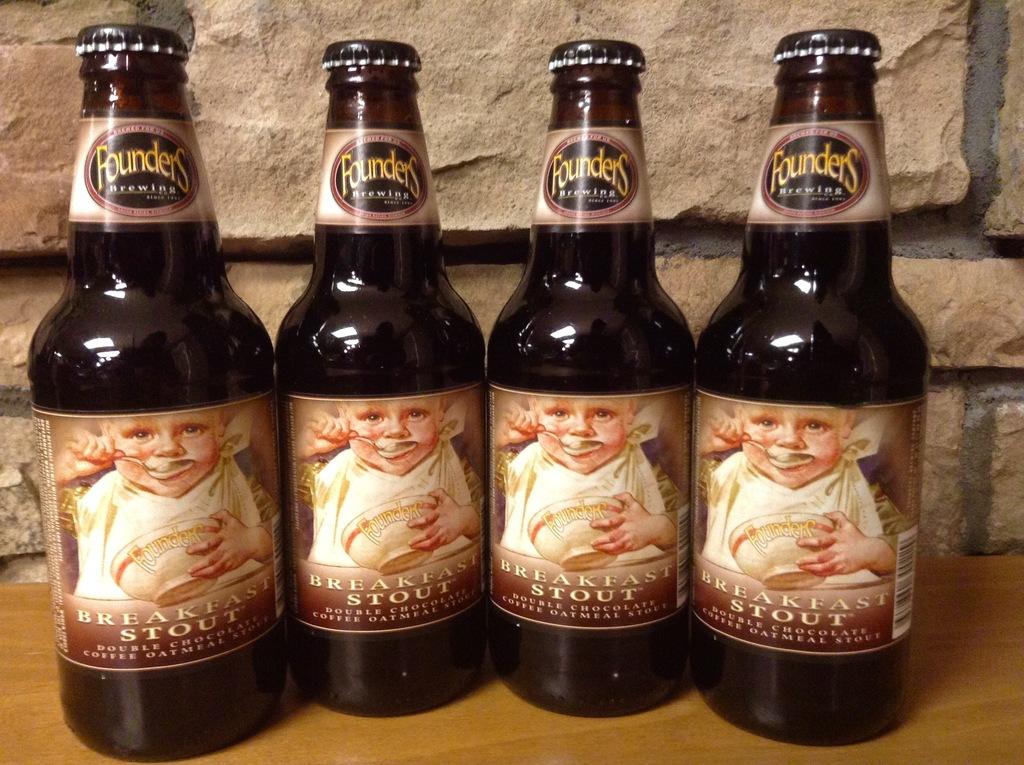What kind of beer is this?
Provide a short and direct response. Breakfast stout. Who makes this beer?
Keep it short and to the point. Founders. 